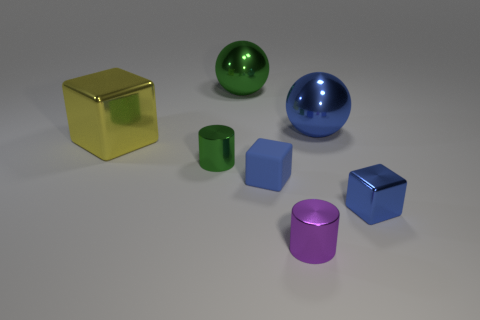If I wanted to create a symmetrical arrangement with the visible objects, which ones would pair together based on their shapes and colors? For a symmetrical arrangement based on shape, you would pair the two cylinders together and then the objects similar to cubes. For the color, it would be a bit complex due to the lack of identical color pairs, but if you consider the green and yellow as lighter shades and the two purple with two blue objects as darker shades, you could create a pattern with an alternating light-dark sequence. 